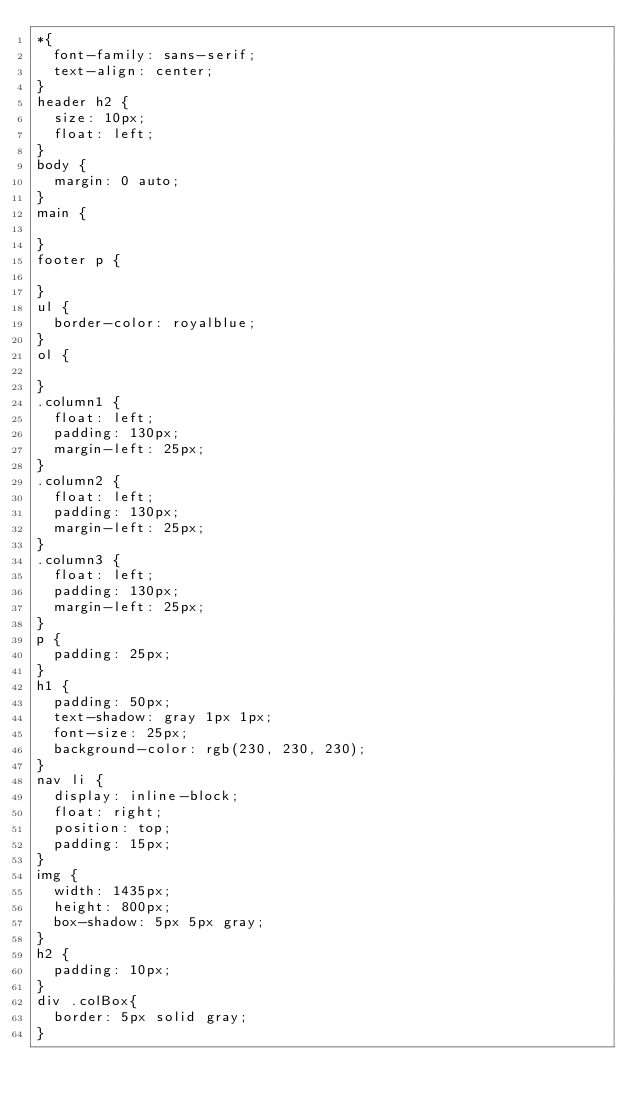Convert code to text. <code><loc_0><loc_0><loc_500><loc_500><_CSS_>*{
  font-family: sans-serif;
  text-align: center;
}
header h2 {
  size: 10px;
  float: left;
}
body {
  margin: 0 auto;
}
main {
  
}
footer p {

}
ul {
  border-color: royalblue;
}
ol {

}
.column1 {
  float: left;
  padding: 130px;
  margin-left: 25px;
}
.column2 {
  float: left;
  padding: 130px;
  margin-left: 25px;
}
.column3 {
  float: left;
  padding: 130px;
  margin-left: 25px;
}
p {
  padding: 25px;
}
h1 {
  padding: 50px;
  text-shadow: gray 1px 1px;
  font-size: 25px;
  background-color: rgb(230, 230, 230);
}
nav li {
  display: inline-block;
  float: right;
  position: top;
  padding: 15px;
}
img {
  width: 1435px;
  height: 800px;
  box-shadow: 5px 5px gray;
}
h2 {
  padding: 10px;
}
div .colBox{
  border: 5px solid gray;
}
</code> 